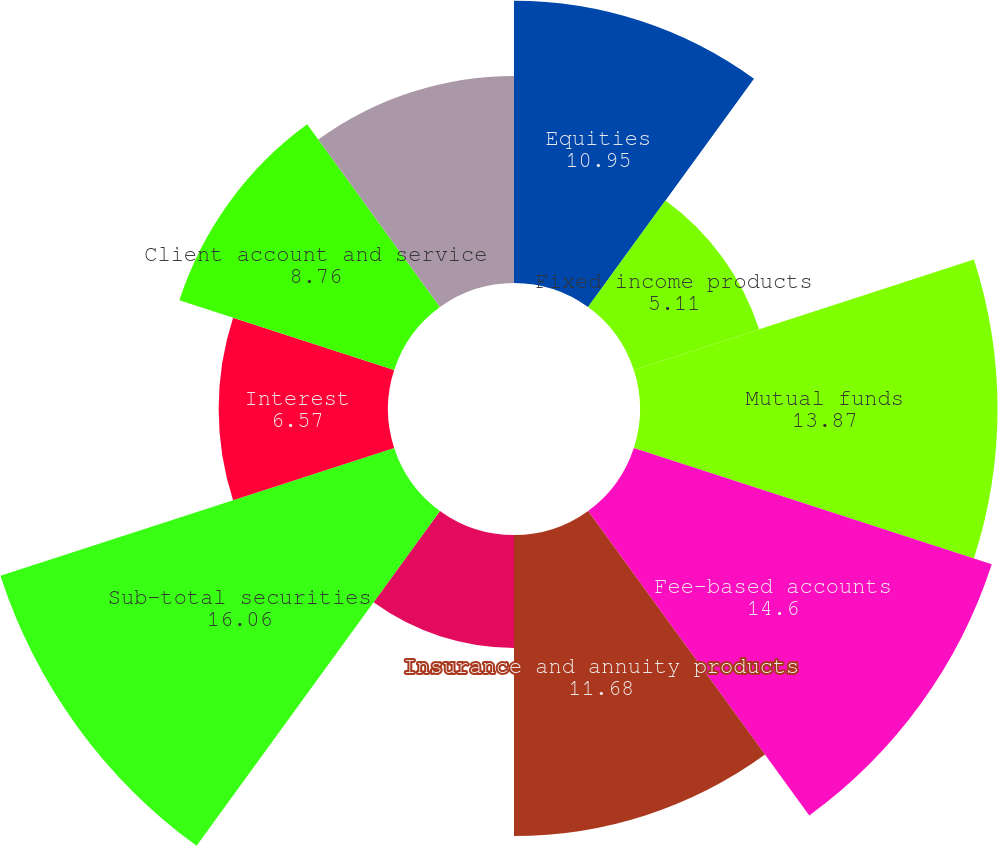Convert chart. <chart><loc_0><loc_0><loc_500><loc_500><pie_chart><fcel>Equities<fcel>Fixed income products<fcel>Mutual funds<fcel>Fee-based accounts<fcel>Insurance and annuity products<fcel>New issue sales credits<fcel>Sub-total securities<fcel>Interest<fcel>Client account and service<fcel>Mutual fund and annuity<nl><fcel>10.95%<fcel>5.11%<fcel>13.87%<fcel>14.6%<fcel>11.68%<fcel>4.38%<fcel>16.06%<fcel>6.57%<fcel>8.76%<fcel>8.03%<nl></chart> 